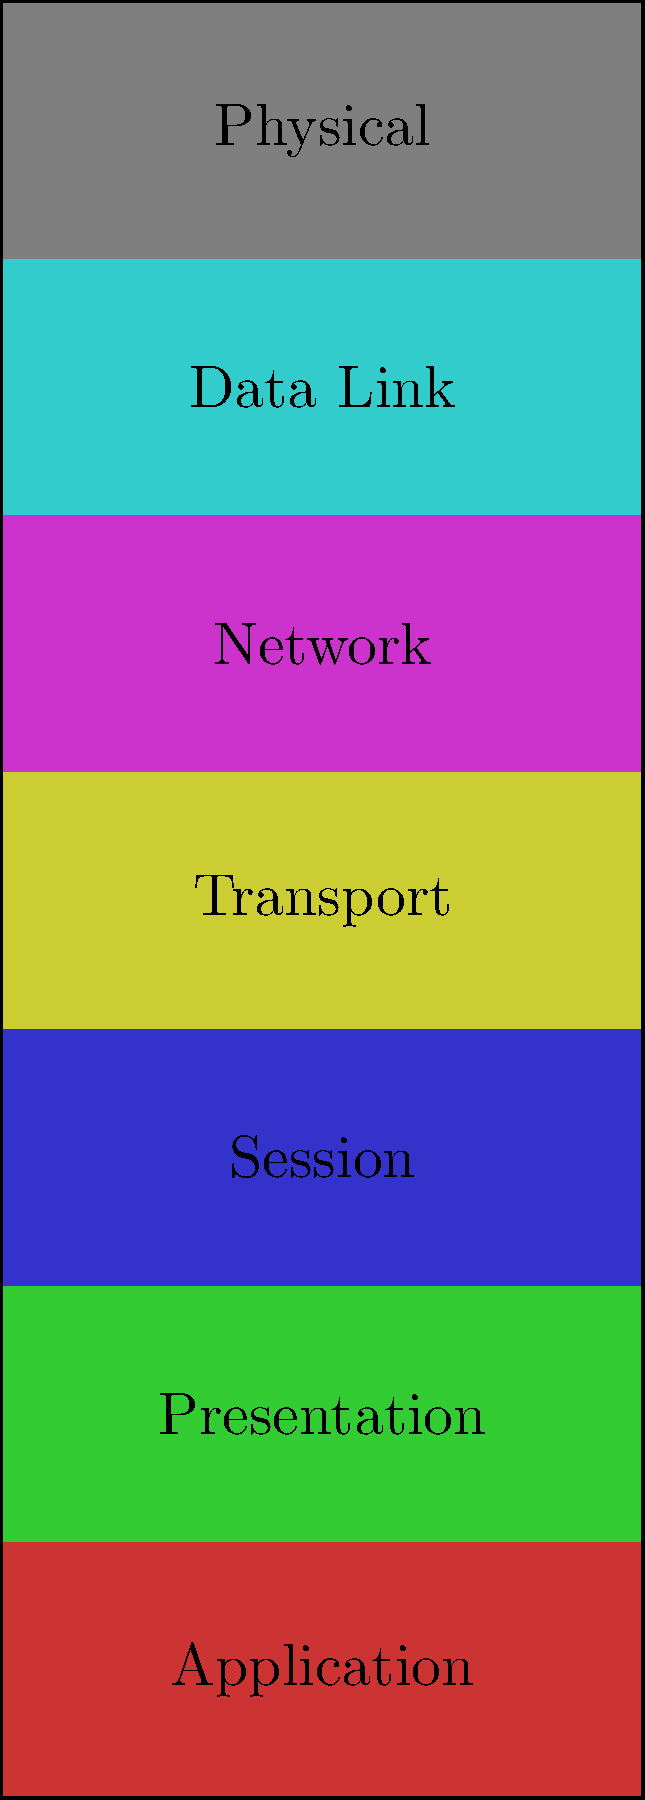In the OSI model stack shown above, which layer is responsible for routing data packets between different networks? To answer this question, let's break down the OSI model layers and their functions:

1. Physical Layer (Bottom): Deals with physical transmission of data.
2. Data Link Layer: Handles data transfer between adjacent network nodes.
3. Network Layer: Responsible for routing data packets between different networks.
4. Transport Layer: Ensures end-to-end communication and data integrity.
5. Session Layer: Manages sessions between applications.
6. Presentation Layer: Formats and encrypts data for the application layer.
7. Application Layer (Top): Provides network services to end-user applications.

The layer responsible for routing data packets between different networks is the Network Layer. In the diagram, this is the fifth layer from the bottom, colored in purple.

The Network Layer uses logical addressing (like IP addresses) to determine the best path for data to travel from the source to the destination, even if they are on different networks. This routing functionality is crucial for internet communication, where data often needs to traverse multiple networks to reach its destination.
Answer: Network Layer 